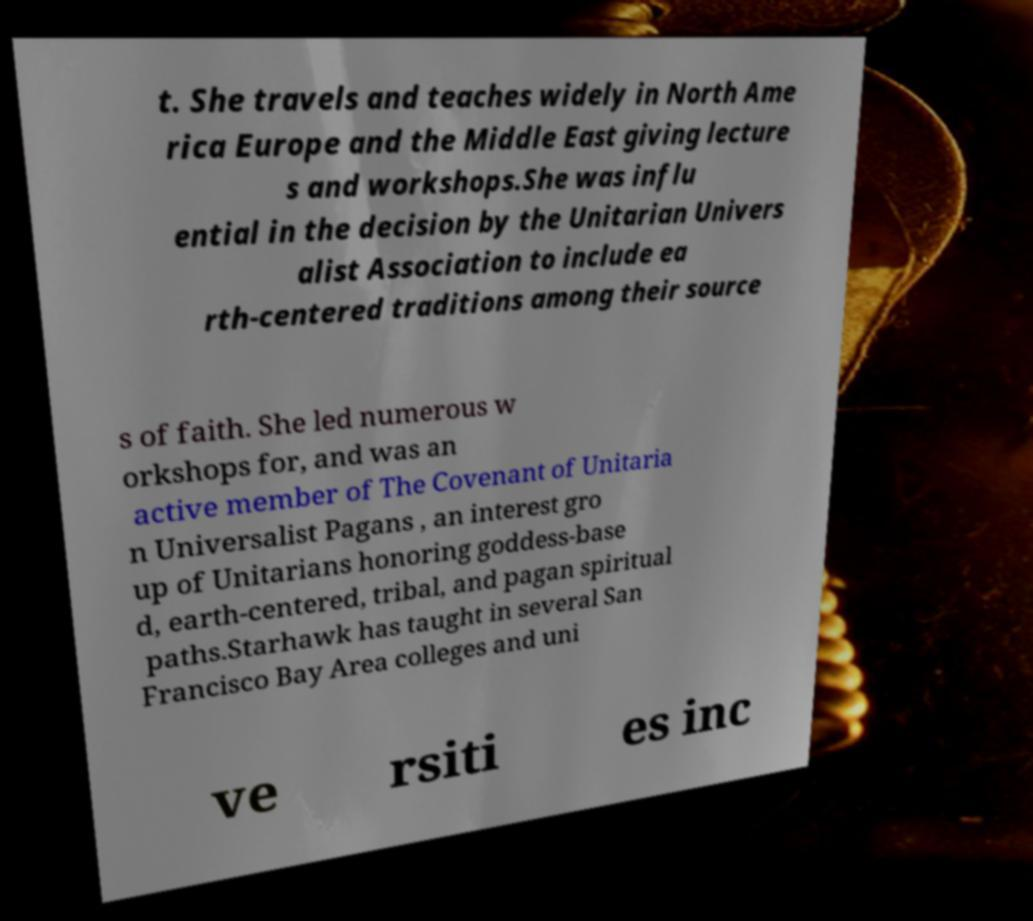What messages or text are displayed in this image? I need them in a readable, typed format. t. She travels and teaches widely in North Ame rica Europe and the Middle East giving lecture s and workshops.She was influ ential in the decision by the Unitarian Univers alist Association to include ea rth-centered traditions among their source s of faith. She led numerous w orkshops for, and was an active member of The Covenant of Unitaria n Universalist Pagans , an interest gro up of Unitarians honoring goddess-base d, earth-centered, tribal, and pagan spiritual paths.Starhawk has taught in several San Francisco Bay Area colleges and uni ve rsiti es inc 